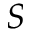<formula> <loc_0><loc_0><loc_500><loc_500>S</formula> 